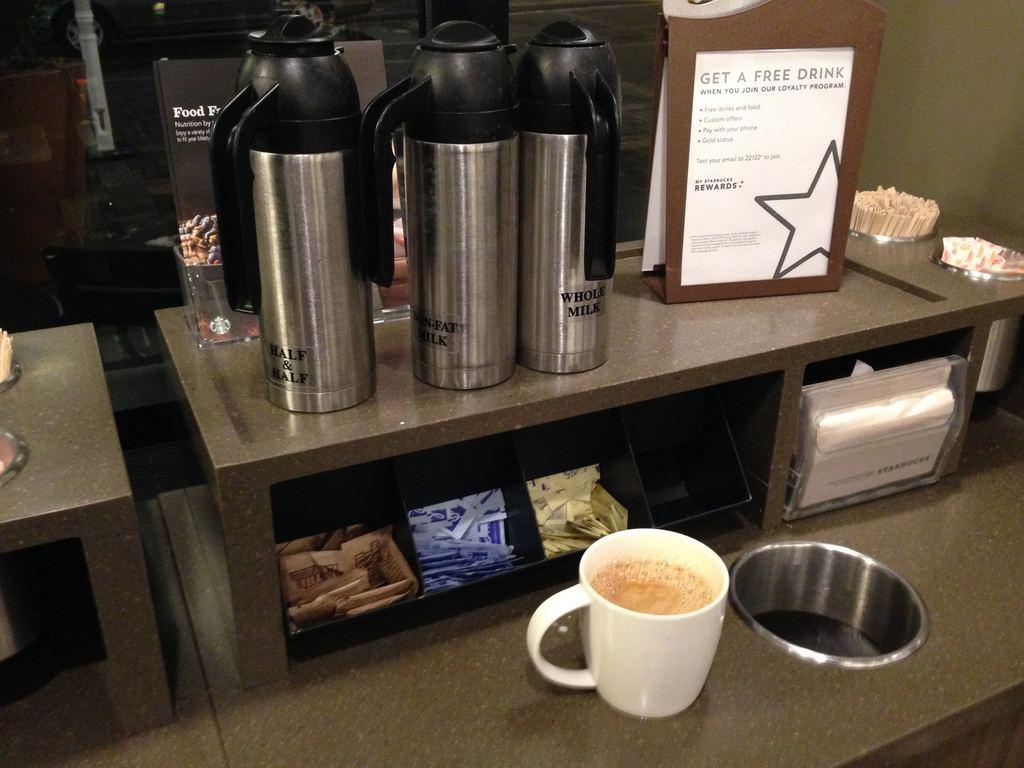<image>
Give a short and clear explanation of the subsequent image. A sign in a coffee shop advertises the shop's loyalty program. 